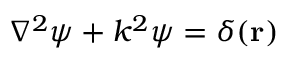<formula> <loc_0><loc_0><loc_500><loc_500>\nabla ^ { 2 } \psi + k ^ { 2 } \psi = \delta ( r )</formula> 